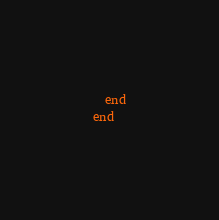<code> <loc_0><loc_0><loc_500><loc_500><_Ruby_>  end
end
</code> 